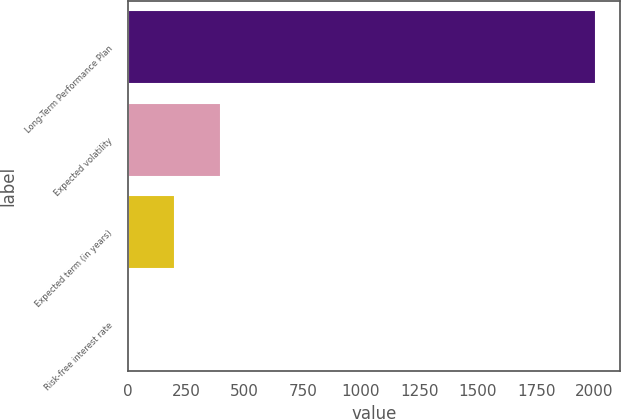Convert chart to OTSL. <chart><loc_0><loc_0><loc_500><loc_500><bar_chart><fcel>Long-Term Performance Plan<fcel>Expected volatility<fcel>Expected term (in years)<fcel>Risk-free interest rate<nl><fcel>2008<fcel>402<fcel>201.25<fcel>0.5<nl></chart> 